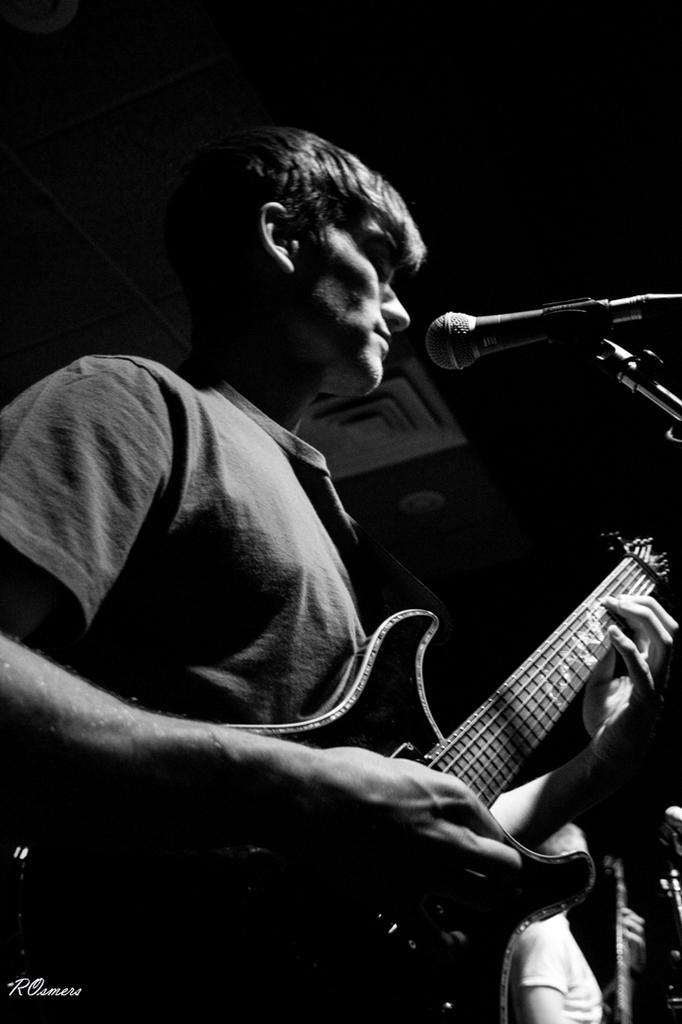In one or two sentences, can you explain what this image depicts? In front of this picture, we see a man a wearing t-shirt. He is playing guitar and also he might be singing in microphone. We, On the right bottom of the picture we can see the other man wearing white t-shirt is also playing guitar. I think this is in a room or a conference hall. We can see the roof of the wall. 